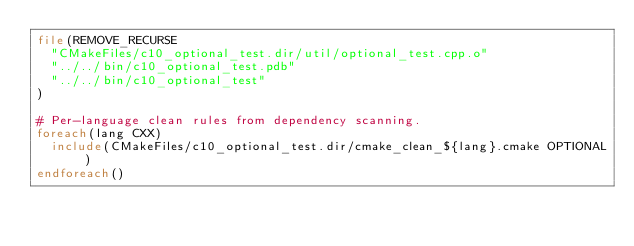Convert code to text. <code><loc_0><loc_0><loc_500><loc_500><_CMake_>file(REMOVE_RECURSE
  "CMakeFiles/c10_optional_test.dir/util/optional_test.cpp.o"
  "../../bin/c10_optional_test.pdb"
  "../../bin/c10_optional_test"
)

# Per-language clean rules from dependency scanning.
foreach(lang CXX)
  include(CMakeFiles/c10_optional_test.dir/cmake_clean_${lang}.cmake OPTIONAL)
endforeach()
</code> 